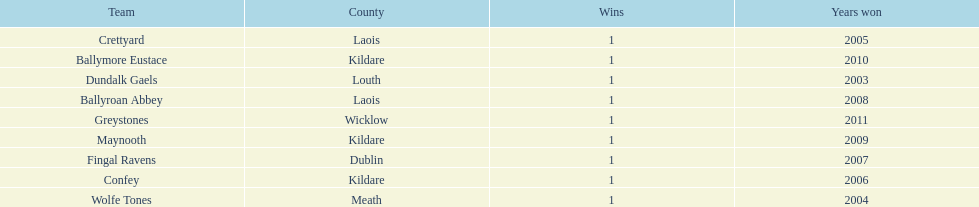Ballymore eustace is from the same county as what team that won in 2009? Maynooth. 